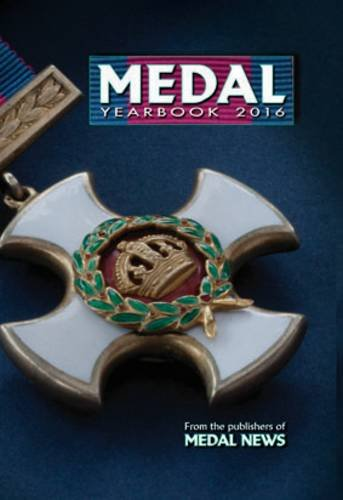How can this book be useful to a medal collector? This book serves as an essential resource for medal collectors by providing up-to-date valuations, detailed photographs, and descriptions of authenticity features that help in identifying and appraising medals. 